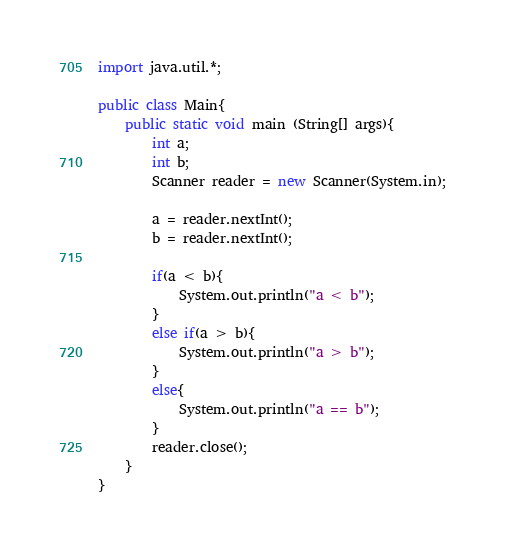<code> <loc_0><loc_0><loc_500><loc_500><_Java_>import java.util.*;

public class Main{
    public static void main (String[] args){
        int a;
        int b;
        Scanner reader = new Scanner(System.in);

        a = reader.nextInt();
        b = reader.nextInt();

        if(a < b){
            System.out.println("a < b");
        }
        else if(a > b){
            System.out.println("a > b");
        }
        else{
            System.out.println("a == b");
        }
        reader.close();
    }
}
</code> 